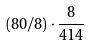<formula> <loc_0><loc_0><loc_500><loc_500>( 8 0 / 8 ) \cdot \frac { 8 } { 4 1 4 }</formula> 